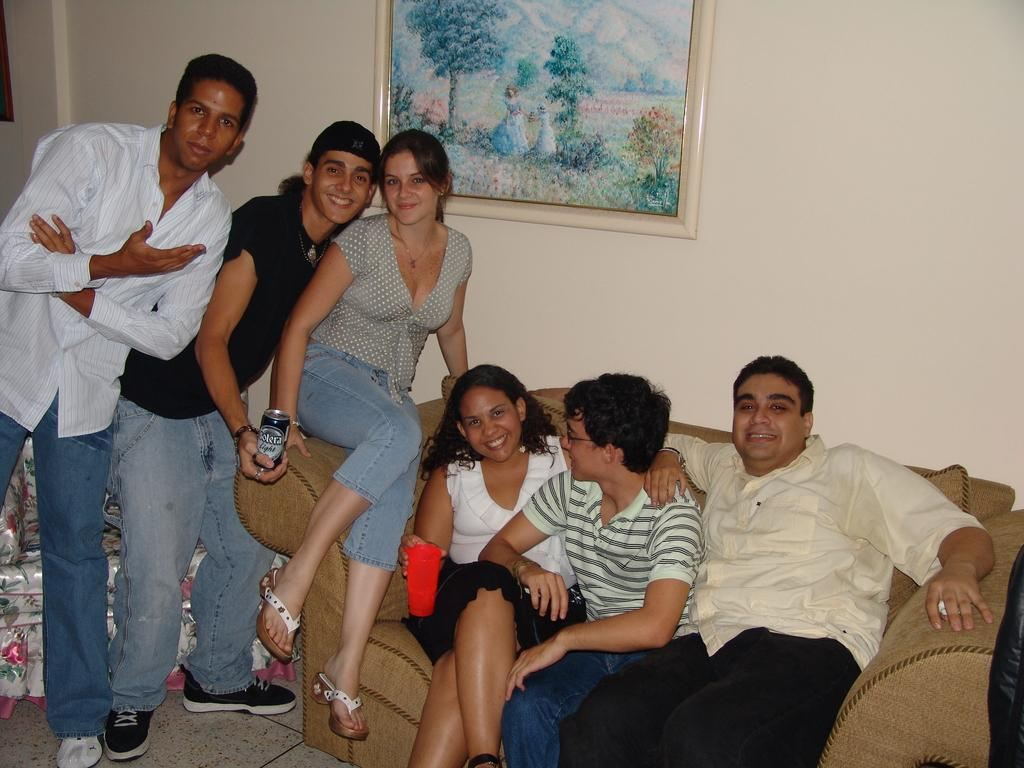How many people are sitting on the couch in the image? There are four persons sitting on the couch in the image. How many people are standing in the image? There are two persons standing in the image. What can be seen in the background of the image? There is a frame attached to the wall in the background. Can you describe any objects present in the image? Yes, there are objects present in the image, but their specific details are not mentioned in the provided facts. Who is the owner of the example in the image? There is no example mentioned in the image, so it is not possible to determine the owner. 